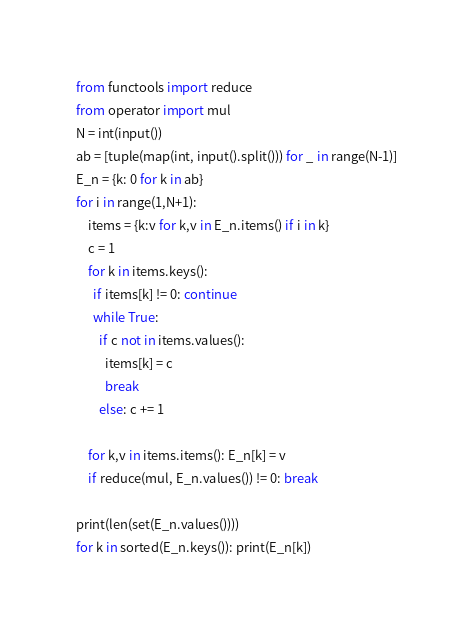Convert code to text. <code><loc_0><loc_0><loc_500><loc_500><_Python_>from functools import reduce
from operator import mul
N = int(input())
ab = [tuple(map(int, input().split())) for _ in range(N-1)]
E_n = {k: 0 for k in ab}
for i in range(1,N+1):
    items = {k:v for k,v in E_n.items() if i in k}
    c = 1
    for k in items.keys():
      if items[k] != 0: continue
      while True:
        if c not in items.values():
          items[k] = c
          break
        else: c += 1

    for k,v in items.items(): E_n[k] = v
    if reduce(mul, E_n.values()) != 0: break

print(len(set(E_n.values())))
for k in sorted(E_n.keys()): print(E_n[k])</code> 